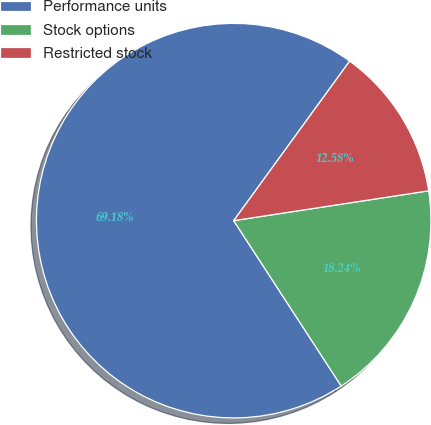Convert chart. <chart><loc_0><loc_0><loc_500><loc_500><pie_chart><fcel>Performance units<fcel>Stock options<fcel>Restricted stock<nl><fcel>69.18%<fcel>18.24%<fcel>12.58%<nl></chart> 